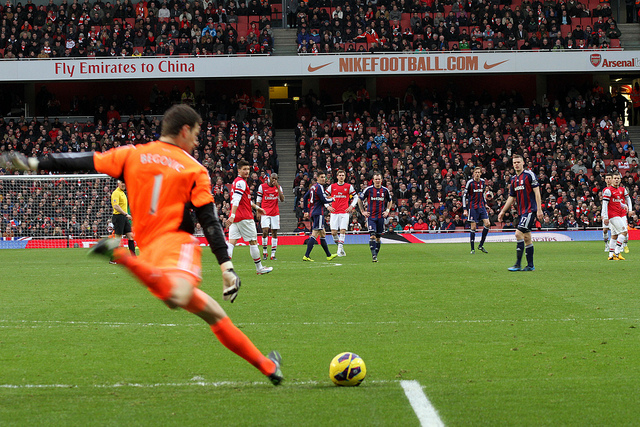<image>Is the ball in motion? I am not sure if the ball is in motion. The responses are mixed. Is the ball in motion? I am not sure if the ball is in motion. It can be seen both in motion and not in motion. 